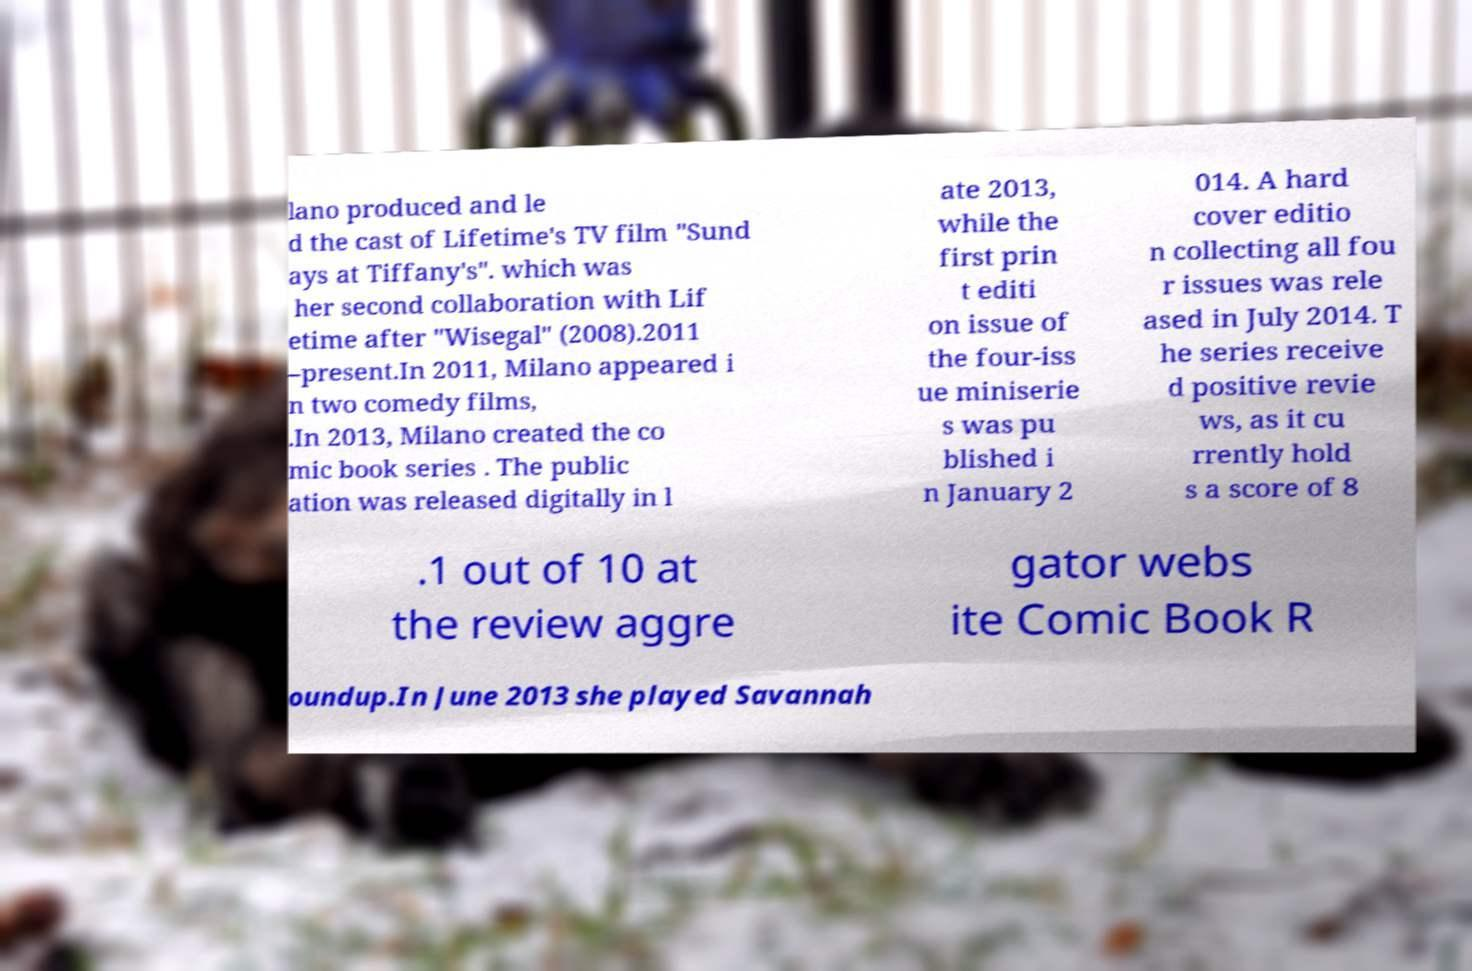Please identify and transcribe the text found in this image. lano produced and le d the cast of Lifetime's TV film "Sund ays at Tiffany's". which was her second collaboration with Lif etime after "Wisegal" (2008).2011 –present.In 2011, Milano appeared i n two comedy films, .In 2013, Milano created the co mic book series . The public ation was released digitally in l ate 2013, while the first prin t editi on issue of the four-iss ue miniserie s was pu blished i n January 2 014. A hard cover editio n collecting all fou r issues was rele ased in July 2014. T he series receive d positive revie ws, as it cu rrently hold s a score of 8 .1 out of 10 at the review aggre gator webs ite Comic Book R oundup.In June 2013 she played Savannah 